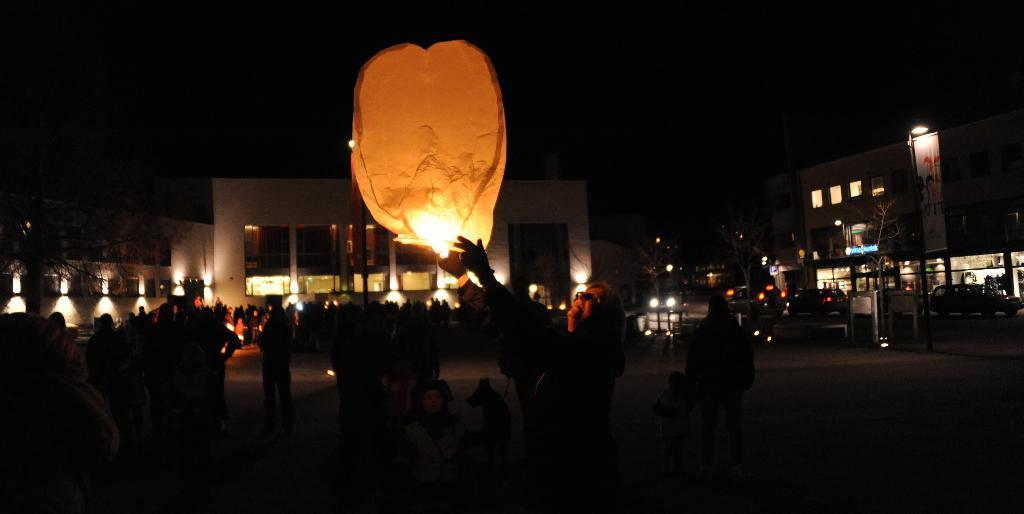What is the person in the image holding? The person is holding a sky lantern in the image. What else can be seen in the image besides the person and the sky lantern? There are vehicles visible in the image. What can be seen in the distance in the image? There are buildings in the background of the image. What is visible at the top of the image? The sky is visible at the top of the image. What type of pipe is being used by the person in the image? There is no pipe present in the image; the person is holding a sky lantern. How many chairs can be seen in the image? There are no chairs visible in the image. 